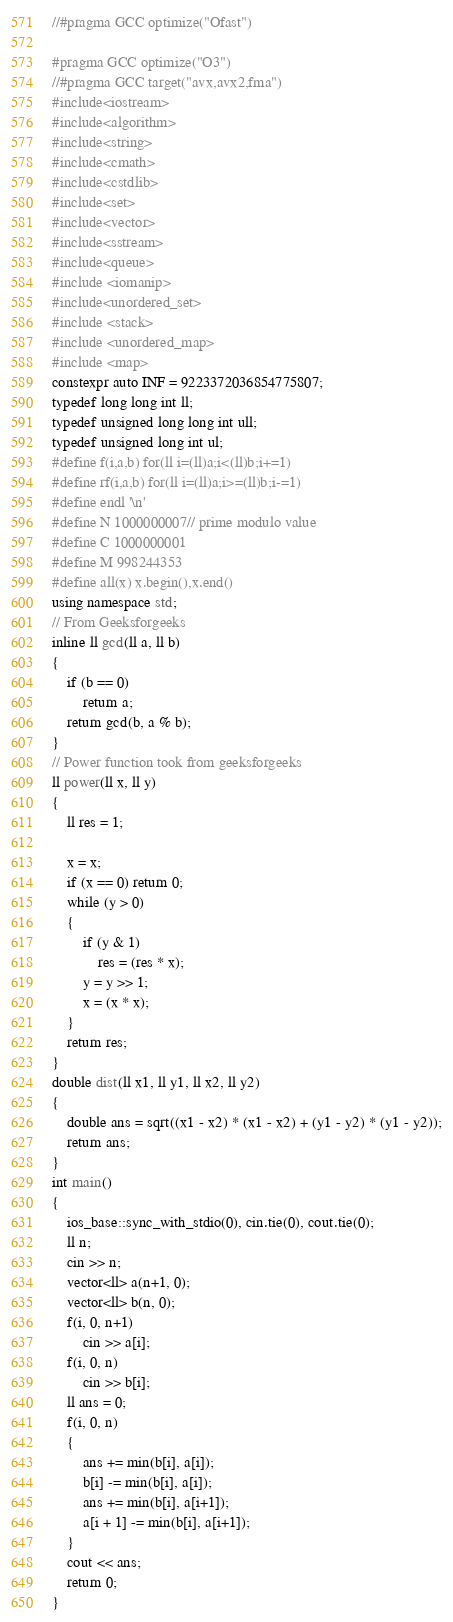<code> <loc_0><loc_0><loc_500><loc_500><_C++_>//#pragma GCC optimize("Ofast")

#pragma GCC optimize("O3")
//#pragma GCC target("avx,avx2,fma")
#include<iostream>
#include<algorithm>
#include<string>
#include<cmath>
#include<cstdlib>
#include<set>
#include<vector>
#include<sstream>
#include<queue>
#include <iomanip>
#include<unordered_set>
#include <stack>
#include <unordered_map>
#include <map>
constexpr auto INF = 9223372036854775807;
typedef long long int ll;
typedef unsigned long long int ull;
typedef unsigned long int ul;
#define f(i,a,b) for(ll i=(ll)a;i<(ll)b;i+=1)
#define rf(i,a,b) for(ll i=(ll)a;i>=(ll)b;i-=1)
#define endl '\n'
#define N 1000000007// prime modulo value 
#define C 1000000001
#define M 998244353
#define all(x) x.begin(),x.end()
using namespace std;
// From Geeksforgeeks
inline ll gcd(ll a, ll b)
{
	if (b == 0)
		return a;
	return gcd(b, a % b);
}
// Power function took from geeksforgeeks
ll power(ll x, ll y)
{
	ll res = 1;

	x = x;
	if (x == 0) return 0;
	while (y > 0)
	{
		if (y & 1)
			res = (res * x);
		y = y >> 1;
		x = (x * x);
	}
	return res;
}
double dist(ll x1, ll y1, ll x2, ll y2)
{
	double ans = sqrt((x1 - x2) * (x1 - x2) + (y1 - y2) * (y1 - y2));
	return ans;
}
int main()
{
	ios_base::sync_with_stdio(0), cin.tie(0), cout.tie(0);
	ll n;
	cin >> n;
	vector<ll> a(n+1, 0);
	vector<ll> b(n, 0);
	f(i, 0, n+1)
		cin >> a[i];
	f(i, 0, n)
		cin >> b[i];
	ll ans = 0;
	f(i, 0, n)
	{
		ans += min(b[i], a[i]);
		b[i] -= min(b[i], a[i]);
		ans += min(b[i], a[i+1]);
		a[i + 1] -= min(b[i], a[i+1]);
	}
	cout << ans;
	return 0;
}
</code> 